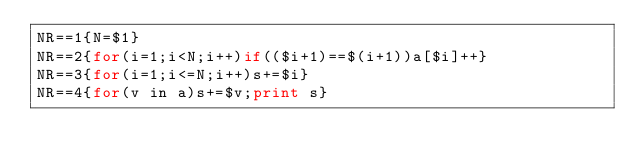Convert code to text. <code><loc_0><loc_0><loc_500><loc_500><_Awk_>NR==1{N=$1}
NR==2{for(i=1;i<N;i++)if(($i+1)==$(i+1))a[$i]++}
NR==3{for(i=1;i<=N;i++)s+=$i}
NR==4{for(v in a)s+=$v;print s}
</code> 